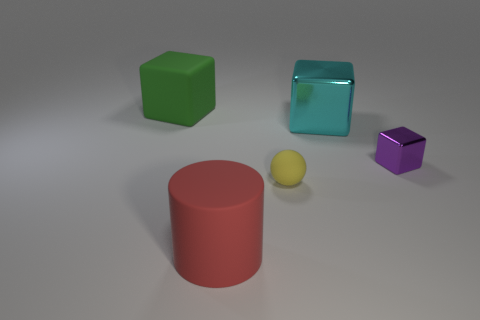Describe the surface the objects are resting on. The objects are resting on a smooth, flat surface that has a neutral grey tone. The surface reflects a bit of light, indicating it may have a slightly glossy or satin finish, which nicely complements the objects' matte and transparent textures. 